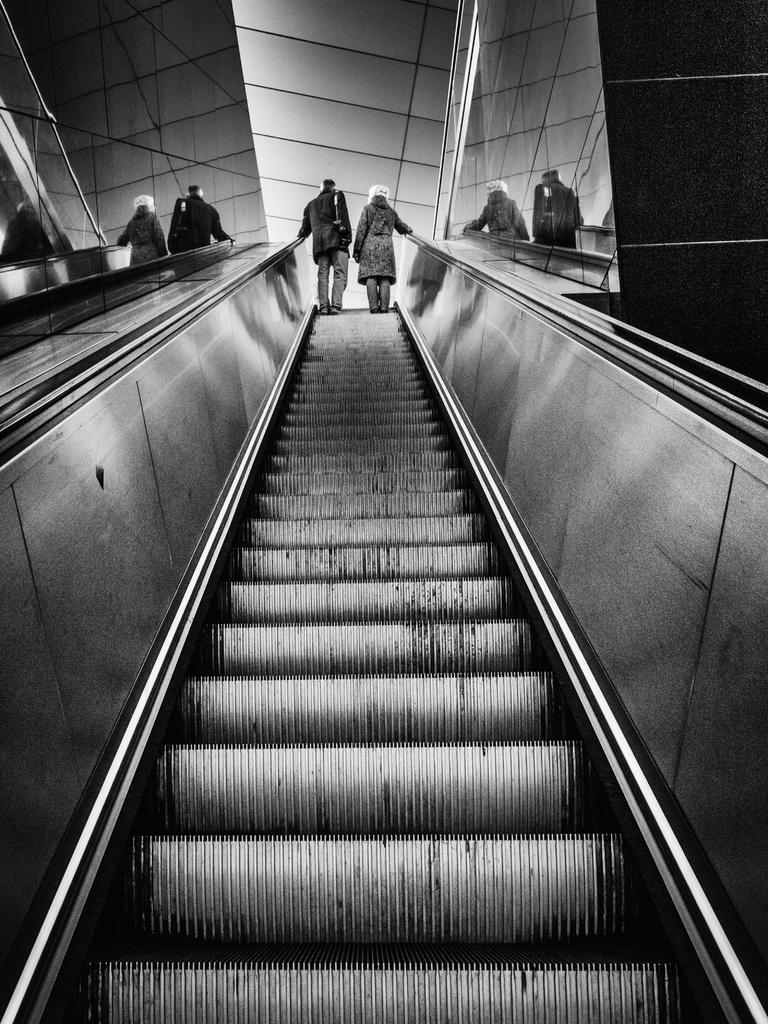What is the color scheme of the image? The image is black and white. What are the two people in the image doing? They are standing on an escalator. Can you describe the surroundings of the escalator? There are reflections of the people beside the escalator. What type of account is being discussed by the people in the image? There is no discussion of an account in the image; it only shows two people standing on an escalator. 